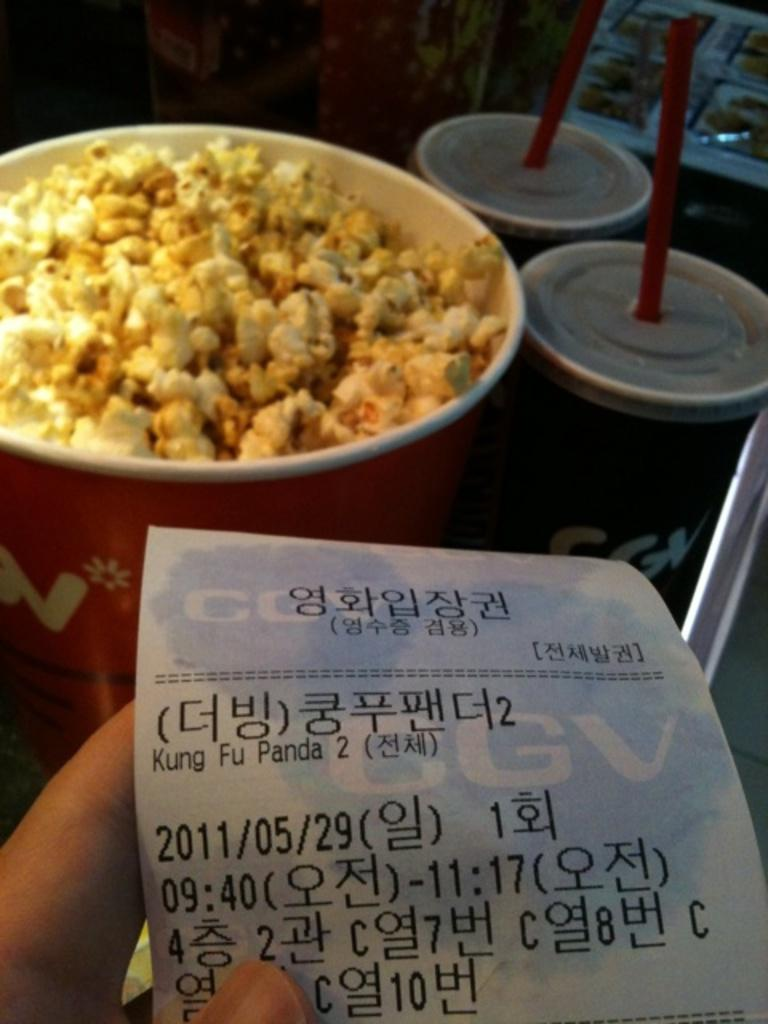Who is present in the image? There is a person in the image. What is the person holding? The person is holding a paper. What type of containers are visible in the image? There are paper cups with straws and lids in the image. What type of snack is present in the image? There is a bowl of popcorn in the image. How many beds are visible in the image? There are no beds present in the image. 